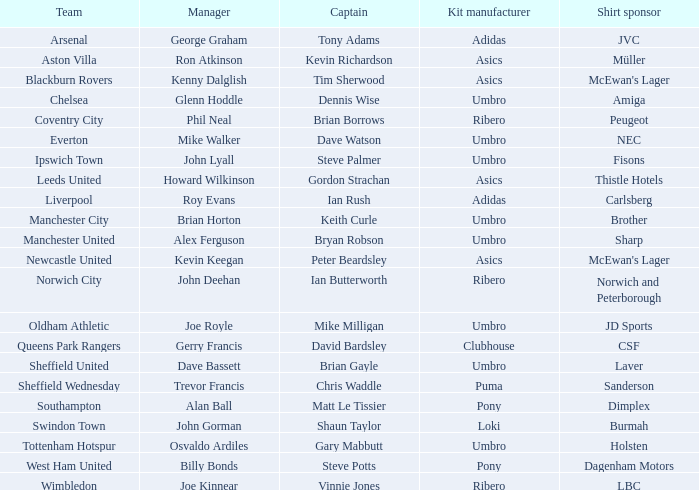Which manager has sheffield wednesday as the team? Trevor Francis. 